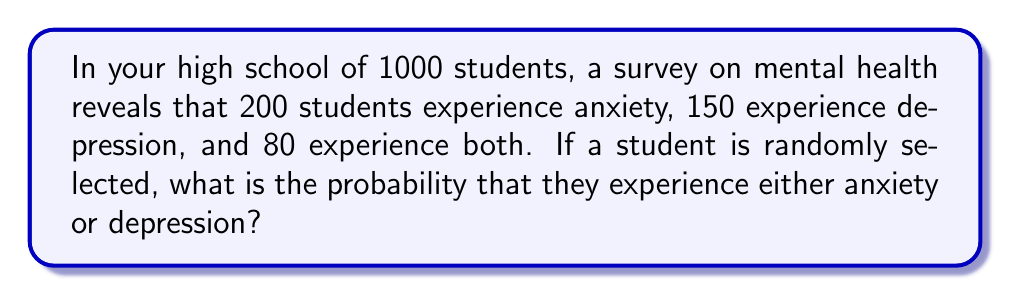Could you help me with this problem? Let's approach this step-by-step using set theory:

1) Let A be the set of students with anxiety, and D be the set of students with depression.

2) We're given:
   - Total students: 1000
   - |A| (number of students with anxiety) = 200
   - |D| (number of students with depression) = 150
   - |A ∩ D| (number of students with both) = 80

3) We need to find P(A ∪ D), the probability of a student having anxiety or depression or both.

4) Using the inclusion-exclusion principle:
   |A ∪ D| = |A| + |D| - |A ∩ D|

5) Substituting the values:
   |A ∪ D| = 200 + 150 - 80 = 270

6) The probability is then:

   $$P(A \cup D) = \frac{|A \cup D|}{\text{Total students}} = \frac{270}{1000} = 0.27$$

Therefore, the probability of a randomly selected student experiencing either anxiety or depression is 0.27 or 27%.
Answer: 0.27 